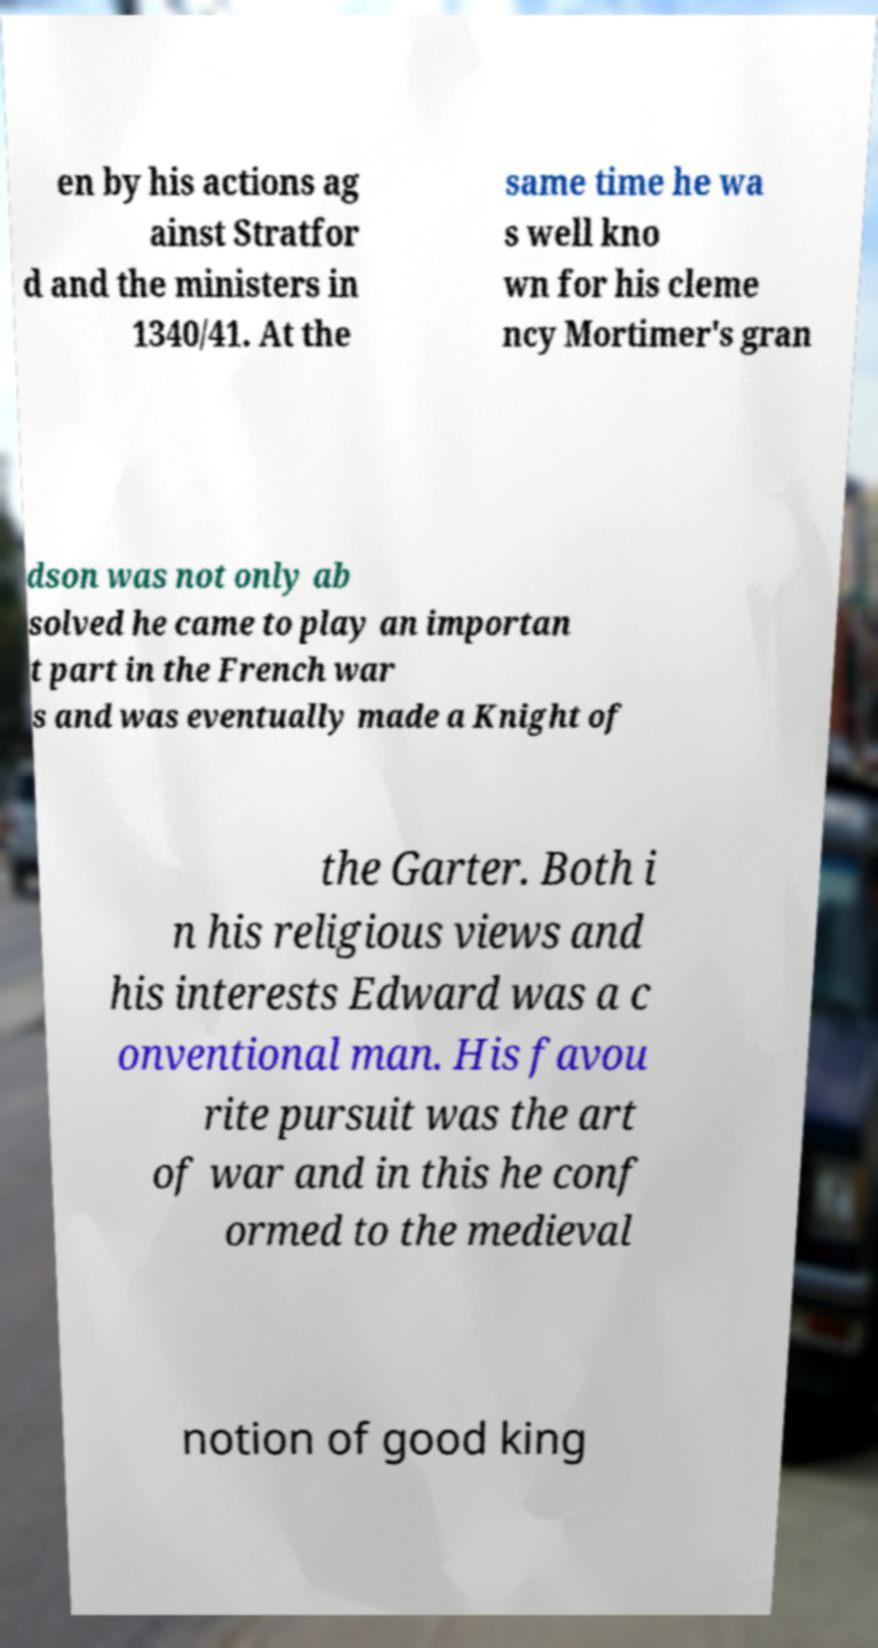Can you read and provide the text displayed in the image?This photo seems to have some interesting text. Can you extract and type it out for me? en by his actions ag ainst Stratfor d and the ministers in 1340/41. At the same time he wa s well kno wn for his cleme ncy Mortimer's gran dson was not only ab solved he came to play an importan t part in the French war s and was eventually made a Knight of the Garter. Both i n his religious views and his interests Edward was a c onventional man. His favou rite pursuit was the art of war and in this he conf ormed to the medieval notion of good king 